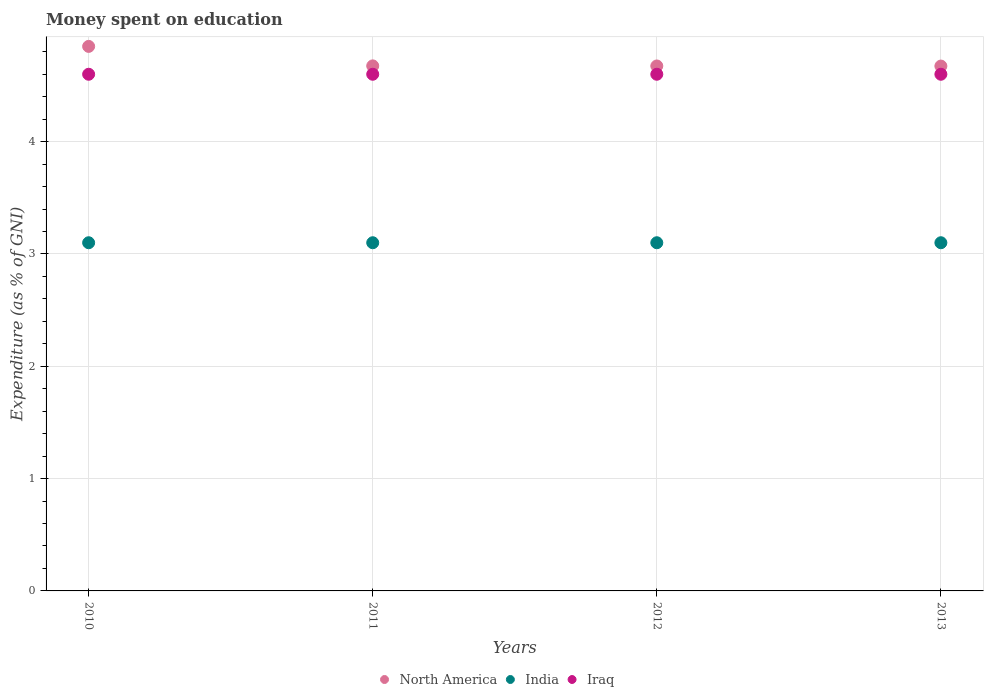How many different coloured dotlines are there?
Offer a very short reply. 3. Is the number of dotlines equal to the number of legend labels?
Make the answer very short. Yes. What is the amount of money spent on education in India in 2012?
Offer a very short reply. 3.1. What is the total amount of money spent on education in North America in the graph?
Offer a terse response. 18.87. What is the difference between the amount of money spent on education in North America in 2010 and that in 2011?
Your answer should be compact. 0.17. What is the difference between the amount of money spent on education in India in 2011 and the amount of money spent on education in Iraq in 2012?
Provide a short and direct response. -1.5. What is the average amount of money spent on education in Iraq per year?
Make the answer very short. 4.6. In the year 2013, what is the difference between the amount of money spent on education in Iraq and amount of money spent on education in India?
Make the answer very short. 1.5. What is the ratio of the amount of money spent on education in Iraq in 2010 to that in 2012?
Your answer should be very brief. 1. Is the amount of money spent on education in India in 2010 less than that in 2012?
Make the answer very short. No. What is the difference between the highest and the second highest amount of money spent on education in North America?
Ensure brevity in your answer.  0.17. What is the difference between the highest and the lowest amount of money spent on education in North America?
Offer a terse response. 0.18. In how many years, is the amount of money spent on education in Iraq greater than the average amount of money spent on education in Iraq taken over all years?
Give a very brief answer. 0. Is the sum of the amount of money spent on education in North America in 2011 and 2012 greater than the maximum amount of money spent on education in India across all years?
Your response must be concise. Yes. Is the amount of money spent on education in India strictly greater than the amount of money spent on education in North America over the years?
Offer a terse response. No. How many dotlines are there?
Your answer should be compact. 3. How many years are there in the graph?
Provide a succinct answer. 4. What is the difference between two consecutive major ticks on the Y-axis?
Your answer should be very brief. 1. Does the graph contain any zero values?
Make the answer very short. No. Where does the legend appear in the graph?
Provide a short and direct response. Bottom center. How are the legend labels stacked?
Your response must be concise. Horizontal. What is the title of the graph?
Your answer should be very brief. Money spent on education. Does "High income: OECD" appear as one of the legend labels in the graph?
Make the answer very short. No. What is the label or title of the X-axis?
Your answer should be compact. Years. What is the label or title of the Y-axis?
Offer a terse response. Expenditure (as % of GNI). What is the Expenditure (as % of GNI) in North America in 2010?
Offer a very short reply. 4.85. What is the Expenditure (as % of GNI) of India in 2010?
Give a very brief answer. 3.1. What is the Expenditure (as % of GNI) in Iraq in 2010?
Make the answer very short. 4.6. What is the Expenditure (as % of GNI) in North America in 2011?
Make the answer very short. 4.67. What is the Expenditure (as % of GNI) in India in 2011?
Ensure brevity in your answer.  3.1. What is the Expenditure (as % of GNI) in North America in 2012?
Make the answer very short. 4.67. What is the Expenditure (as % of GNI) in India in 2012?
Offer a terse response. 3.1. What is the Expenditure (as % of GNI) of Iraq in 2012?
Offer a very short reply. 4.6. What is the Expenditure (as % of GNI) of North America in 2013?
Ensure brevity in your answer.  4.67. Across all years, what is the maximum Expenditure (as % of GNI) in North America?
Your answer should be compact. 4.85. Across all years, what is the maximum Expenditure (as % of GNI) of India?
Ensure brevity in your answer.  3.1. Across all years, what is the maximum Expenditure (as % of GNI) in Iraq?
Provide a short and direct response. 4.6. Across all years, what is the minimum Expenditure (as % of GNI) of North America?
Give a very brief answer. 4.67. Across all years, what is the minimum Expenditure (as % of GNI) of Iraq?
Give a very brief answer. 4.6. What is the total Expenditure (as % of GNI) in North America in the graph?
Your answer should be very brief. 18.87. What is the difference between the Expenditure (as % of GNI) of North America in 2010 and that in 2011?
Offer a terse response. 0.17. What is the difference between the Expenditure (as % of GNI) in India in 2010 and that in 2011?
Offer a terse response. 0. What is the difference between the Expenditure (as % of GNI) of North America in 2010 and that in 2012?
Your answer should be compact. 0.17. What is the difference between the Expenditure (as % of GNI) of India in 2010 and that in 2012?
Give a very brief answer. 0. What is the difference between the Expenditure (as % of GNI) of Iraq in 2010 and that in 2012?
Provide a short and direct response. 0. What is the difference between the Expenditure (as % of GNI) in North America in 2010 and that in 2013?
Your answer should be compact. 0.18. What is the difference between the Expenditure (as % of GNI) of India in 2010 and that in 2013?
Provide a short and direct response. 0. What is the difference between the Expenditure (as % of GNI) of Iraq in 2010 and that in 2013?
Offer a terse response. 0. What is the difference between the Expenditure (as % of GNI) in North America in 2011 and that in 2012?
Offer a very short reply. 0. What is the difference between the Expenditure (as % of GNI) in India in 2011 and that in 2012?
Keep it short and to the point. 0. What is the difference between the Expenditure (as % of GNI) of Iraq in 2011 and that in 2012?
Offer a terse response. 0. What is the difference between the Expenditure (as % of GNI) of North America in 2011 and that in 2013?
Your answer should be very brief. 0. What is the difference between the Expenditure (as % of GNI) of Iraq in 2011 and that in 2013?
Give a very brief answer. 0. What is the difference between the Expenditure (as % of GNI) of North America in 2012 and that in 2013?
Give a very brief answer. 0. What is the difference between the Expenditure (as % of GNI) of India in 2012 and that in 2013?
Provide a short and direct response. 0. What is the difference between the Expenditure (as % of GNI) in North America in 2010 and the Expenditure (as % of GNI) in India in 2011?
Make the answer very short. 1.75. What is the difference between the Expenditure (as % of GNI) of North America in 2010 and the Expenditure (as % of GNI) of Iraq in 2011?
Keep it short and to the point. 0.25. What is the difference between the Expenditure (as % of GNI) in North America in 2010 and the Expenditure (as % of GNI) in India in 2012?
Keep it short and to the point. 1.75. What is the difference between the Expenditure (as % of GNI) of North America in 2010 and the Expenditure (as % of GNI) of Iraq in 2012?
Your answer should be very brief. 0.25. What is the difference between the Expenditure (as % of GNI) of India in 2010 and the Expenditure (as % of GNI) of Iraq in 2012?
Keep it short and to the point. -1.5. What is the difference between the Expenditure (as % of GNI) of North America in 2010 and the Expenditure (as % of GNI) of India in 2013?
Offer a very short reply. 1.75. What is the difference between the Expenditure (as % of GNI) in North America in 2010 and the Expenditure (as % of GNI) in Iraq in 2013?
Your answer should be compact. 0.25. What is the difference between the Expenditure (as % of GNI) in North America in 2011 and the Expenditure (as % of GNI) in India in 2012?
Ensure brevity in your answer.  1.57. What is the difference between the Expenditure (as % of GNI) of North America in 2011 and the Expenditure (as % of GNI) of Iraq in 2012?
Make the answer very short. 0.07. What is the difference between the Expenditure (as % of GNI) in North America in 2011 and the Expenditure (as % of GNI) in India in 2013?
Keep it short and to the point. 1.57. What is the difference between the Expenditure (as % of GNI) of North America in 2011 and the Expenditure (as % of GNI) of Iraq in 2013?
Give a very brief answer. 0.07. What is the difference between the Expenditure (as % of GNI) in India in 2011 and the Expenditure (as % of GNI) in Iraq in 2013?
Give a very brief answer. -1.5. What is the difference between the Expenditure (as % of GNI) of North America in 2012 and the Expenditure (as % of GNI) of India in 2013?
Give a very brief answer. 1.57. What is the difference between the Expenditure (as % of GNI) of North America in 2012 and the Expenditure (as % of GNI) of Iraq in 2013?
Keep it short and to the point. 0.07. What is the average Expenditure (as % of GNI) of North America per year?
Provide a short and direct response. 4.72. In the year 2010, what is the difference between the Expenditure (as % of GNI) in North America and Expenditure (as % of GNI) in India?
Offer a very short reply. 1.75. In the year 2010, what is the difference between the Expenditure (as % of GNI) of North America and Expenditure (as % of GNI) of Iraq?
Provide a succinct answer. 0.25. In the year 2011, what is the difference between the Expenditure (as % of GNI) in North America and Expenditure (as % of GNI) in India?
Keep it short and to the point. 1.57. In the year 2011, what is the difference between the Expenditure (as % of GNI) of North America and Expenditure (as % of GNI) of Iraq?
Your response must be concise. 0.07. In the year 2011, what is the difference between the Expenditure (as % of GNI) in India and Expenditure (as % of GNI) in Iraq?
Provide a succinct answer. -1.5. In the year 2012, what is the difference between the Expenditure (as % of GNI) of North America and Expenditure (as % of GNI) of India?
Provide a short and direct response. 1.57. In the year 2012, what is the difference between the Expenditure (as % of GNI) of North America and Expenditure (as % of GNI) of Iraq?
Ensure brevity in your answer.  0.07. In the year 2012, what is the difference between the Expenditure (as % of GNI) of India and Expenditure (as % of GNI) of Iraq?
Ensure brevity in your answer.  -1.5. In the year 2013, what is the difference between the Expenditure (as % of GNI) of North America and Expenditure (as % of GNI) of India?
Give a very brief answer. 1.57. In the year 2013, what is the difference between the Expenditure (as % of GNI) of North America and Expenditure (as % of GNI) of Iraq?
Ensure brevity in your answer.  0.07. In the year 2013, what is the difference between the Expenditure (as % of GNI) in India and Expenditure (as % of GNI) in Iraq?
Make the answer very short. -1.5. What is the ratio of the Expenditure (as % of GNI) in North America in 2010 to that in 2011?
Your answer should be compact. 1.04. What is the ratio of the Expenditure (as % of GNI) of Iraq in 2010 to that in 2011?
Make the answer very short. 1. What is the ratio of the Expenditure (as % of GNI) of North America in 2010 to that in 2012?
Make the answer very short. 1.04. What is the ratio of the Expenditure (as % of GNI) of Iraq in 2010 to that in 2012?
Your answer should be very brief. 1. What is the ratio of the Expenditure (as % of GNI) of North America in 2010 to that in 2013?
Ensure brevity in your answer.  1.04. What is the ratio of the Expenditure (as % of GNI) in Iraq in 2010 to that in 2013?
Your answer should be compact. 1. What is the ratio of the Expenditure (as % of GNI) of India in 2012 to that in 2013?
Provide a short and direct response. 1. What is the difference between the highest and the second highest Expenditure (as % of GNI) in North America?
Provide a succinct answer. 0.17. What is the difference between the highest and the second highest Expenditure (as % of GNI) in India?
Offer a terse response. 0. What is the difference between the highest and the lowest Expenditure (as % of GNI) of North America?
Provide a succinct answer. 0.18. What is the difference between the highest and the lowest Expenditure (as % of GNI) in India?
Provide a short and direct response. 0. 